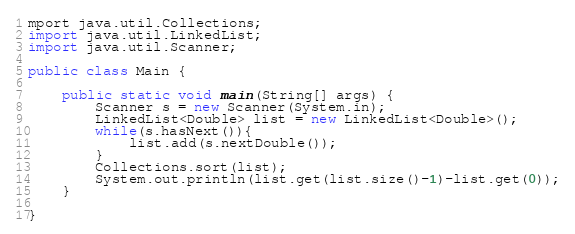Convert code to text. <code><loc_0><loc_0><loc_500><loc_500><_Java_>mport java.util.Collections;
import java.util.LinkedList;
import java.util.Scanner;

public class Main {

	public static void main(String[] args) {
		Scanner s = new Scanner(System.in);
		LinkedList<Double> list = new LinkedList<Double>();
		while(s.hasNext()){
			list.add(s.nextDouble());
		}
		Collections.sort(list);
		System.out.println(list.get(list.size()-1)-list.get(0));
	}

}</code> 